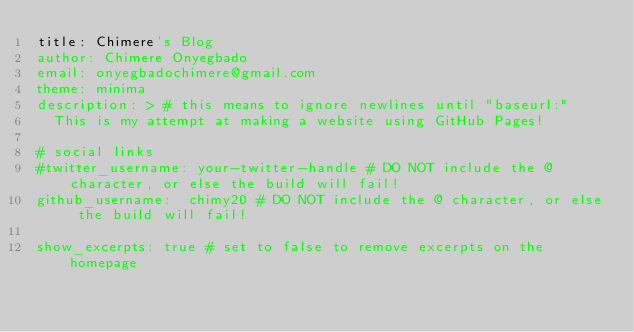Convert code to text. <code><loc_0><loc_0><loc_500><loc_500><_YAML_>title: Chimere's Blog
author: Chimere Onyegbado
email: onyegbadochimere@gmail.com
theme: minima
description: > # this means to ignore newlines until "baseurl:"
  This is my attempt at making a website using GitHub Pages!

# social links
#twitter_username: your-twitter-handle # DO NOT include the @ character, or else the build will fail!
github_username:  chimy20 # DO NOT include the @ character, or else the build will fail!

show_excerpts: true # set to false to remove excerpts on the homepage
</code> 